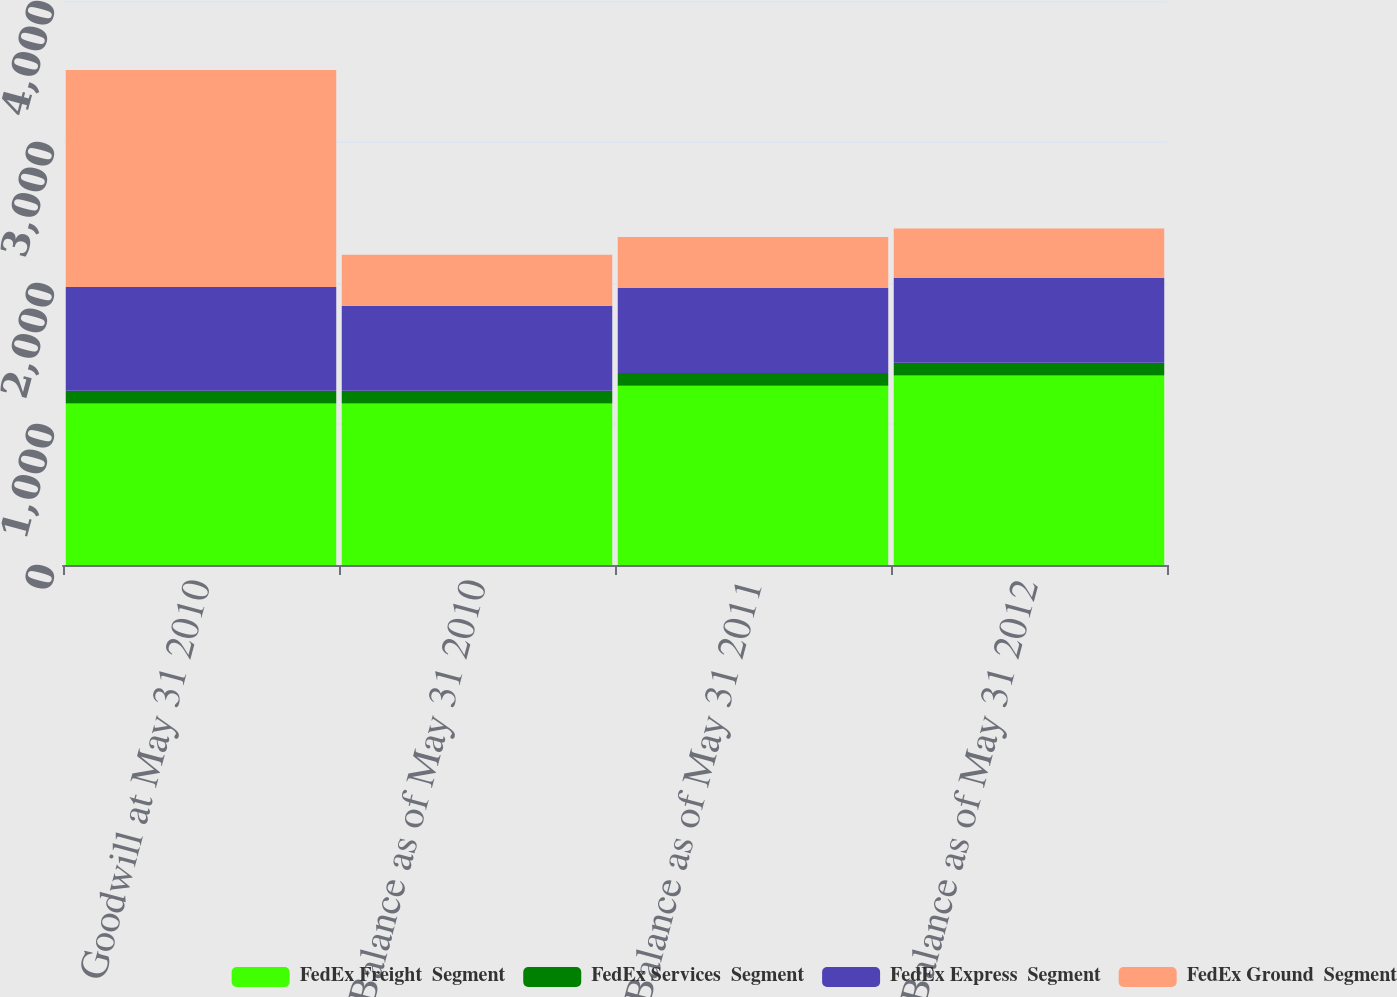Convert chart to OTSL. <chart><loc_0><loc_0><loc_500><loc_500><stacked_bar_chart><ecel><fcel>Goodwill at May 31 2010<fcel>Balance as of May 31 2010<fcel>Balance as of May 31 2011<fcel>Balance as of May 31 2012<nl><fcel>FedEx Freight  Segment<fcel>1145<fcel>1145<fcel>1272<fcel>1344<nl><fcel>FedEx Services  Segment<fcel>90<fcel>90<fcel>90<fcel>90<nl><fcel>FedEx Express  Segment<fcel>736<fcel>603<fcel>602<fcel>602<nl><fcel>FedEx Ground  Segment<fcel>1539<fcel>362<fcel>362<fcel>351<nl></chart> 